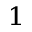<formula> <loc_0><loc_0><loc_500><loc_500>^ { 1 }</formula> 